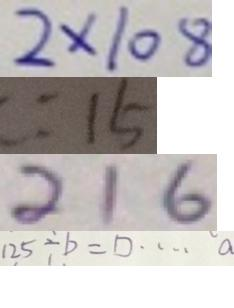Convert formula to latex. <formula><loc_0><loc_0><loc_500><loc_500>2 \times 1 0 8 
 : 1 5 
 2 1 6 
 1 2 5 \div b = \square \cdots a</formula> 